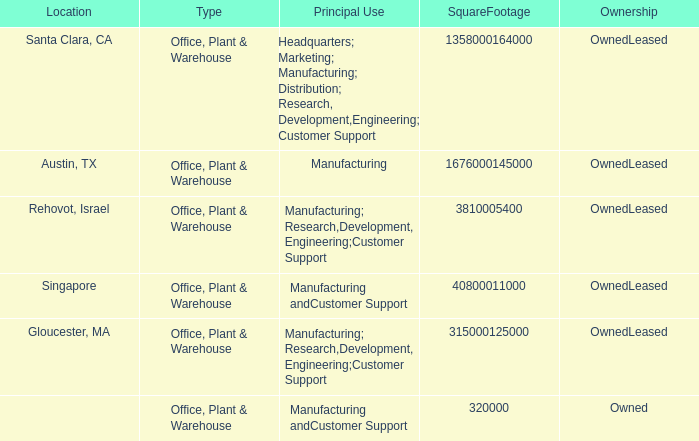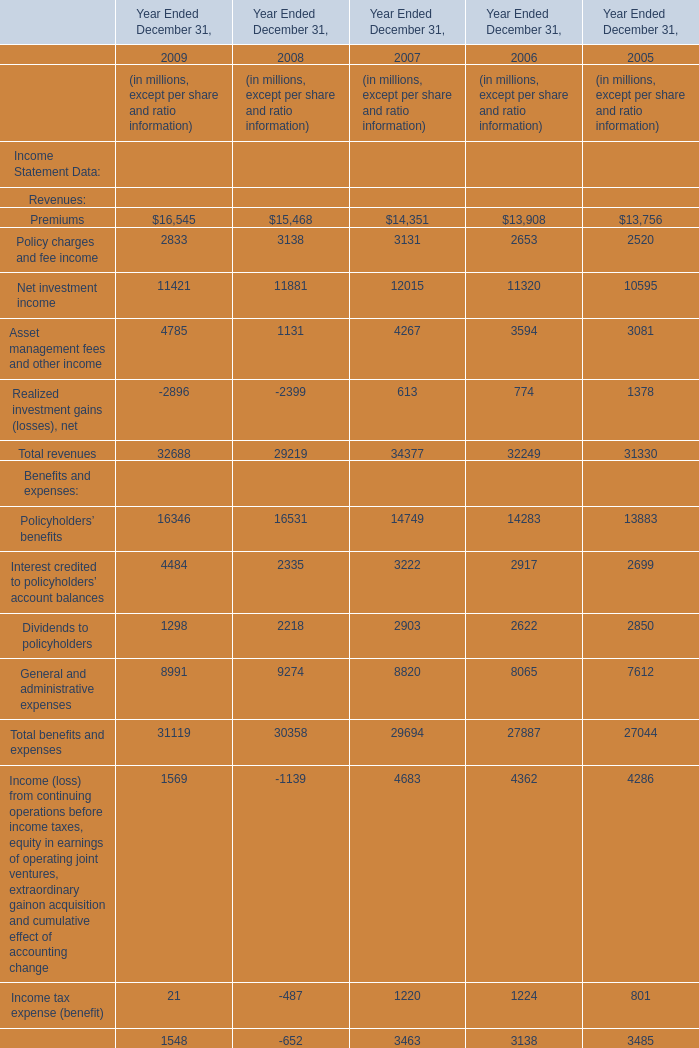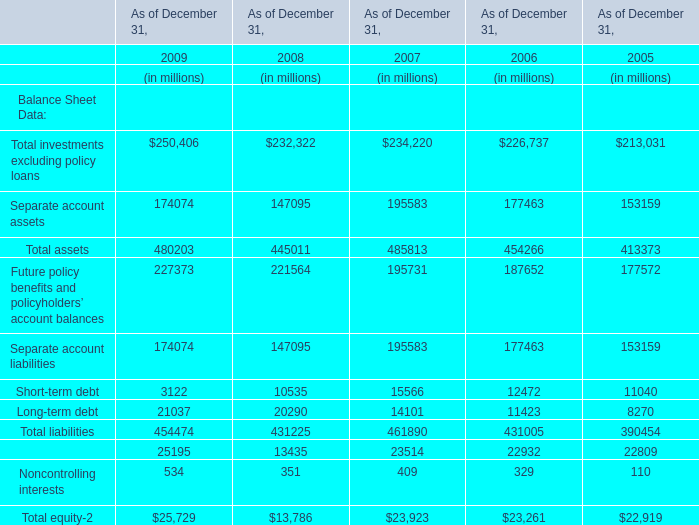what percentage of warehouse locations are in north america? 
Computations: (16 / 75)
Answer: 0.21333. 